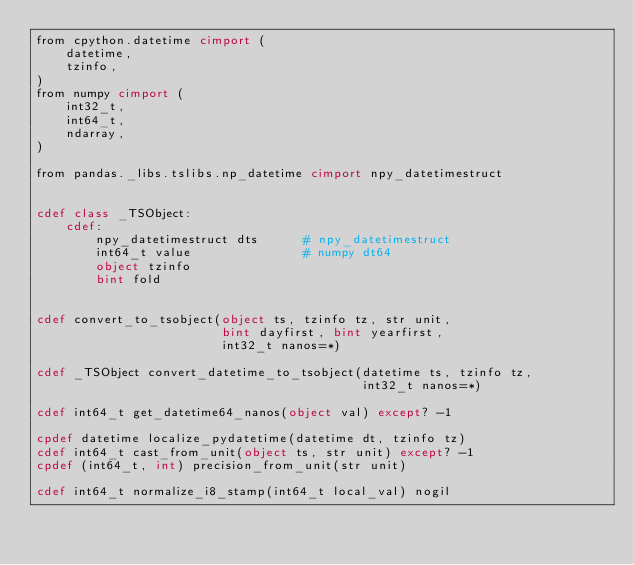Convert code to text. <code><loc_0><loc_0><loc_500><loc_500><_Cython_>from cpython.datetime cimport (
    datetime,
    tzinfo,
)
from numpy cimport (
    int32_t,
    int64_t,
    ndarray,
)

from pandas._libs.tslibs.np_datetime cimport npy_datetimestruct


cdef class _TSObject:
    cdef:
        npy_datetimestruct dts      # npy_datetimestruct
        int64_t value               # numpy dt64
        object tzinfo
        bint fold


cdef convert_to_tsobject(object ts, tzinfo tz, str unit,
                         bint dayfirst, bint yearfirst,
                         int32_t nanos=*)

cdef _TSObject convert_datetime_to_tsobject(datetime ts, tzinfo tz,
                                            int32_t nanos=*)

cdef int64_t get_datetime64_nanos(object val) except? -1

cpdef datetime localize_pydatetime(datetime dt, tzinfo tz)
cdef int64_t cast_from_unit(object ts, str unit) except? -1
cpdef (int64_t, int) precision_from_unit(str unit)

cdef int64_t normalize_i8_stamp(int64_t local_val) nogil
</code> 